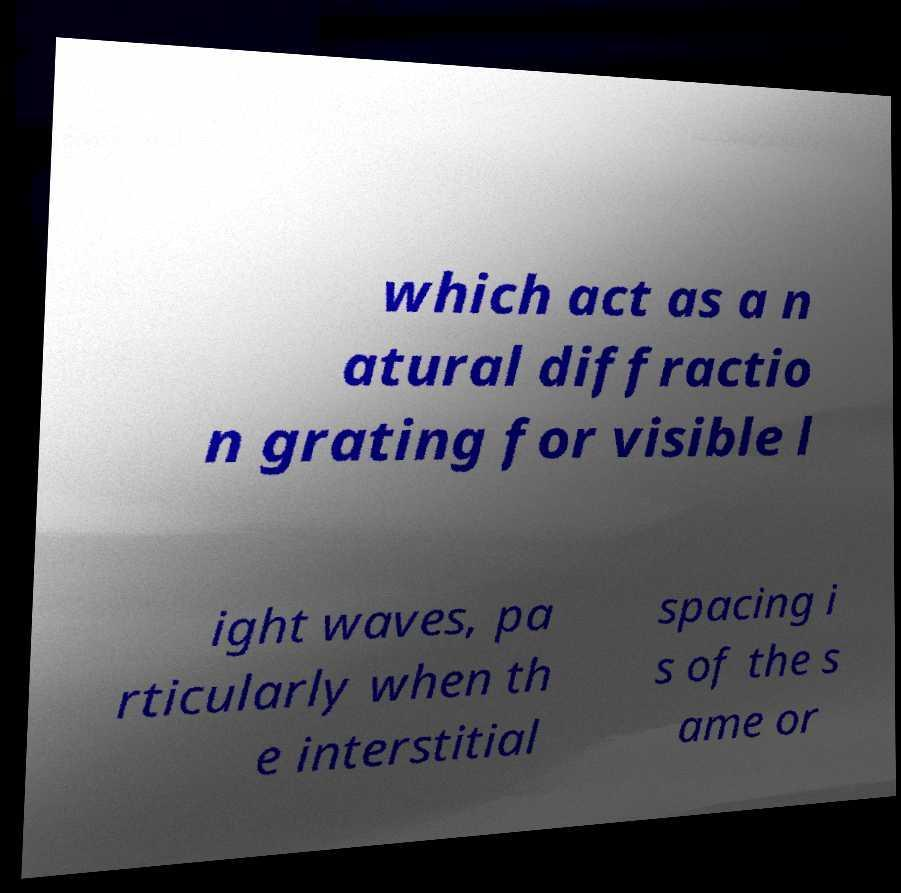Can you accurately transcribe the text from the provided image for me? which act as a n atural diffractio n grating for visible l ight waves, pa rticularly when th e interstitial spacing i s of the s ame or 